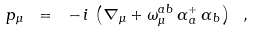<formula> <loc_0><loc_0><loc_500><loc_500>p _ { \mu } \ = \ - \, i \, \left ( \nabla _ { \mu } + \omega _ { \mu } ^ { a b } \, \alpha _ { \, a } ^ { + } \, \alpha _ { \, b } \right ) \ ,</formula> 